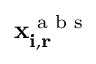Convert formula to latex. <formula><loc_0><loc_0><loc_500><loc_500>x _ { i , r } ^ { a b s }</formula> 